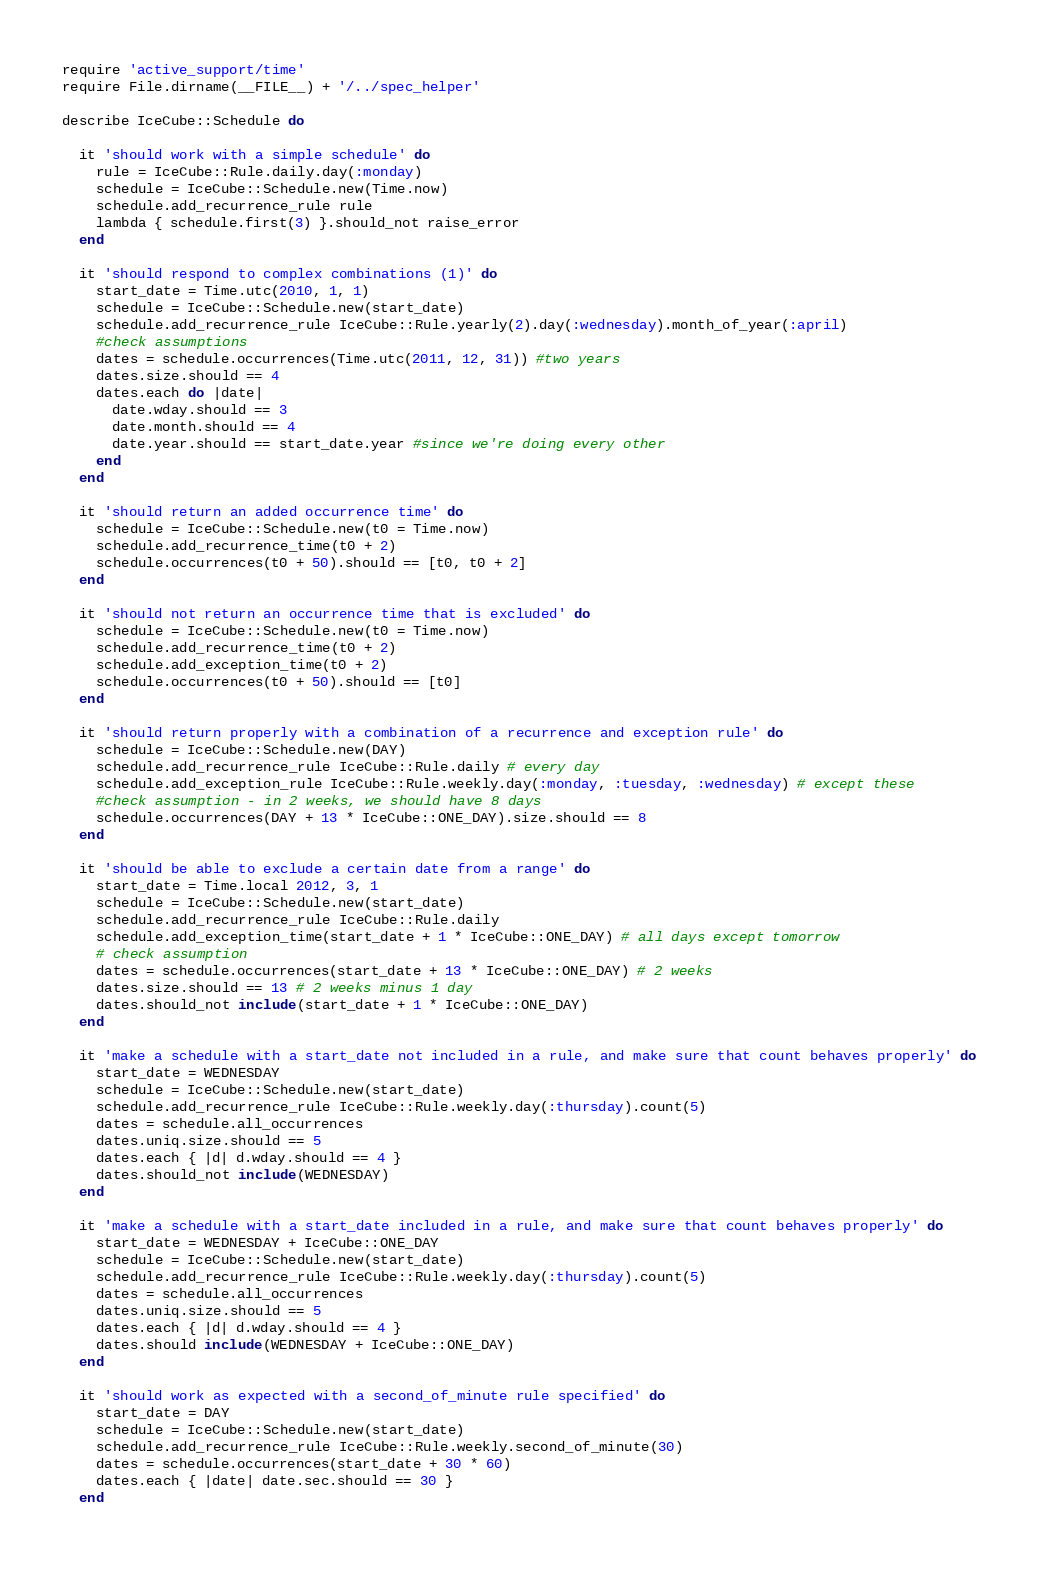Convert code to text. <code><loc_0><loc_0><loc_500><loc_500><_Ruby_>require 'active_support/time'
require File.dirname(__FILE__) + '/../spec_helper'

describe IceCube::Schedule do

  it 'should work with a simple schedule' do
    rule = IceCube::Rule.daily.day(:monday)
    schedule = IceCube::Schedule.new(Time.now)
    schedule.add_recurrence_rule rule
    lambda { schedule.first(3) }.should_not raise_error
  end

  it 'should respond to complex combinations (1)' do
    start_date = Time.utc(2010, 1, 1)
    schedule = IceCube::Schedule.new(start_date)
    schedule.add_recurrence_rule IceCube::Rule.yearly(2).day(:wednesday).month_of_year(:april)
    #check assumptions
    dates = schedule.occurrences(Time.utc(2011, 12, 31)) #two years
    dates.size.should == 4
    dates.each do |date|
      date.wday.should == 3
      date.month.should == 4
      date.year.should == start_date.year #since we're doing every other
    end
  end

  it 'should return an added occurrence time' do
    schedule = IceCube::Schedule.new(t0 = Time.now)
    schedule.add_recurrence_time(t0 + 2)
    schedule.occurrences(t0 + 50).should == [t0, t0 + 2]
  end

  it 'should not return an occurrence time that is excluded' do
    schedule = IceCube::Schedule.new(t0 = Time.now)
    schedule.add_recurrence_time(t0 + 2)
    schedule.add_exception_time(t0 + 2)
    schedule.occurrences(t0 + 50).should == [t0]
  end

  it 'should return properly with a combination of a recurrence and exception rule' do
    schedule = IceCube::Schedule.new(DAY)
    schedule.add_recurrence_rule IceCube::Rule.daily # every day
    schedule.add_exception_rule IceCube::Rule.weekly.day(:monday, :tuesday, :wednesday) # except these
    #check assumption - in 2 weeks, we should have 8 days
    schedule.occurrences(DAY + 13 * IceCube::ONE_DAY).size.should == 8
  end

  it 'should be able to exclude a certain date from a range' do
    start_date = Time.local 2012, 3, 1
    schedule = IceCube::Schedule.new(start_date)
    schedule.add_recurrence_rule IceCube::Rule.daily
    schedule.add_exception_time(start_date + 1 * IceCube::ONE_DAY) # all days except tomorrow
    # check assumption
    dates = schedule.occurrences(start_date + 13 * IceCube::ONE_DAY) # 2 weeks
    dates.size.should == 13 # 2 weeks minus 1 day
    dates.should_not include(start_date + 1 * IceCube::ONE_DAY)
  end

  it 'make a schedule with a start_date not included in a rule, and make sure that count behaves properly' do
    start_date = WEDNESDAY
    schedule = IceCube::Schedule.new(start_date)
    schedule.add_recurrence_rule IceCube::Rule.weekly.day(:thursday).count(5)
    dates = schedule.all_occurrences
    dates.uniq.size.should == 5
    dates.each { |d| d.wday.should == 4 }
    dates.should_not include(WEDNESDAY)
  end

  it 'make a schedule with a start_date included in a rule, and make sure that count behaves properly' do
    start_date = WEDNESDAY + IceCube::ONE_DAY
    schedule = IceCube::Schedule.new(start_date)
    schedule.add_recurrence_rule IceCube::Rule.weekly.day(:thursday).count(5)
    dates = schedule.all_occurrences
    dates.uniq.size.should == 5
    dates.each { |d| d.wday.should == 4 }
    dates.should include(WEDNESDAY + IceCube::ONE_DAY)
  end

  it 'should work as expected with a second_of_minute rule specified' do
    start_date = DAY
    schedule = IceCube::Schedule.new(start_date)
    schedule.add_recurrence_rule IceCube::Rule.weekly.second_of_minute(30)
    dates = schedule.occurrences(start_date + 30 * 60)
    dates.each { |date| date.sec.should == 30 }
  end
</code> 